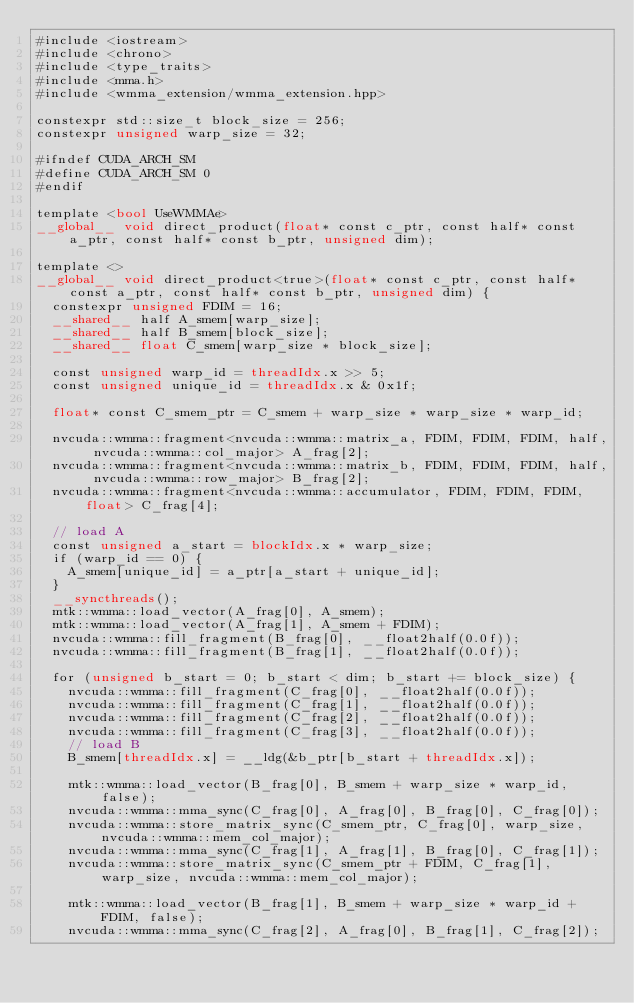Convert code to text. <code><loc_0><loc_0><loc_500><loc_500><_Cuda_>#include <iostream>
#include <chrono>
#include <type_traits>
#include <mma.h>
#include <wmma_extension/wmma_extension.hpp>

constexpr std::size_t block_size = 256;
constexpr unsigned warp_size = 32;

#ifndef CUDA_ARCH_SM
#define CUDA_ARCH_SM 0
#endif

template <bool UseWMMAe>
__global__ void direct_product(float* const c_ptr, const half* const a_ptr, const half* const b_ptr, unsigned dim);

template <>
__global__ void direct_product<true>(float* const c_ptr, const half* const a_ptr, const half* const b_ptr, unsigned dim) {
	constexpr unsigned FDIM = 16;
	__shared__ half A_smem[warp_size];
	__shared__ half B_smem[block_size];
	__shared__ float C_smem[warp_size * block_size];

	const unsigned warp_id = threadIdx.x >> 5;
	const unsigned unique_id = threadIdx.x & 0x1f;

	float* const C_smem_ptr = C_smem + warp_size * warp_size * warp_id;

	nvcuda::wmma::fragment<nvcuda::wmma::matrix_a, FDIM, FDIM, FDIM, half, nvcuda::wmma::col_major> A_frag[2];
	nvcuda::wmma::fragment<nvcuda::wmma::matrix_b, FDIM, FDIM, FDIM, half, nvcuda::wmma::row_major> B_frag[2];
	nvcuda::wmma::fragment<nvcuda::wmma::accumulator, FDIM, FDIM, FDIM, float> C_frag[4];

	// load A
	const unsigned a_start = blockIdx.x * warp_size;
	if (warp_id == 0) {
		A_smem[unique_id] = a_ptr[a_start + unique_id];
	}
	__syncthreads();
	mtk::wmma::load_vector(A_frag[0], A_smem);
	mtk::wmma::load_vector(A_frag[1], A_smem + FDIM);
	nvcuda::wmma::fill_fragment(B_frag[0], __float2half(0.0f));
	nvcuda::wmma::fill_fragment(B_frag[1], __float2half(0.0f));

	for (unsigned b_start = 0; b_start < dim; b_start += block_size) {
		nvcuda::wmma::fill_fragment(C_frag[0], __float2half(0.0f));
		nvcuda::wmma::fill_fragment(C_frag[1], __float2half(0.0f));
		nvcuda::wmma::fill_fragment(C_frag[2], __float2half(0.0f));
		nvcuda::wmma::fill_fragment(C_frag[3], __float2half(0.0f));
		// load B
		B_smem[threadIdx.x] = __ldg(&b_ptr[b_start + threadIdx.x]);

		mtk::wmma::load_vector(B_frag[0], B_smem + warp_size * warp_id, false);
		nvcuda::wmma::mma_sync(C_frag[0], A_frag[0], B_frag[0], C_frag[0]);
		nvcuda::wmma::store_matrix_sync(C_smem_ptr, C_frag[0], warp_size, nvcuda::wmma::mem_col_major);
		nvcuda::wmma::mma_sync(C_frag[1], A_frag[1], B_frag[0], C_frag[1]);
		nvcuda::wmma::store_matrix_sync(C_smem_ptr + FDIM, C_frag[1], warp_size, nvcuda::wmma::mem_col_major);

		mtk::wmma::load_vector(B_frag[1], B_smem + warp_size * warp_id + FDIM, false);
		nvcuda::wmma::mma_sync(C_frag[2], A_frag[0], B_frag[1], C_frag[2]);</code> 